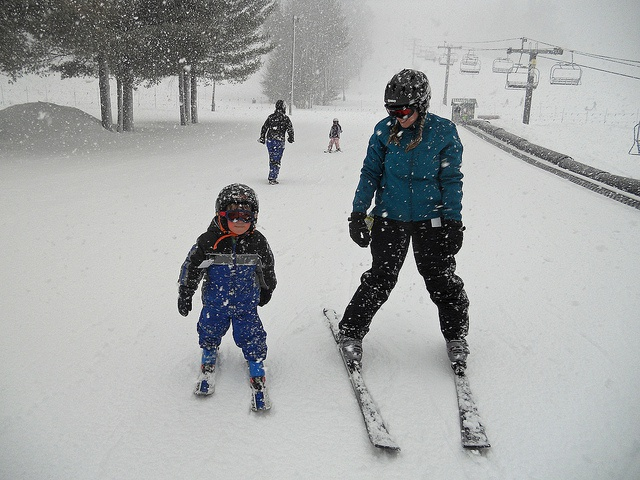Describe the objects in this image and their specific colors. I can see people in black, darkblue, gray, and lightgray tones, people in black, navy, gray, and darkgray tones, skis in black, darkgray, gray, and lightgray tones, people in black, gray, navy, and darkgray tones, and skis in black, darkgray, gray, and navy tones in this image. 